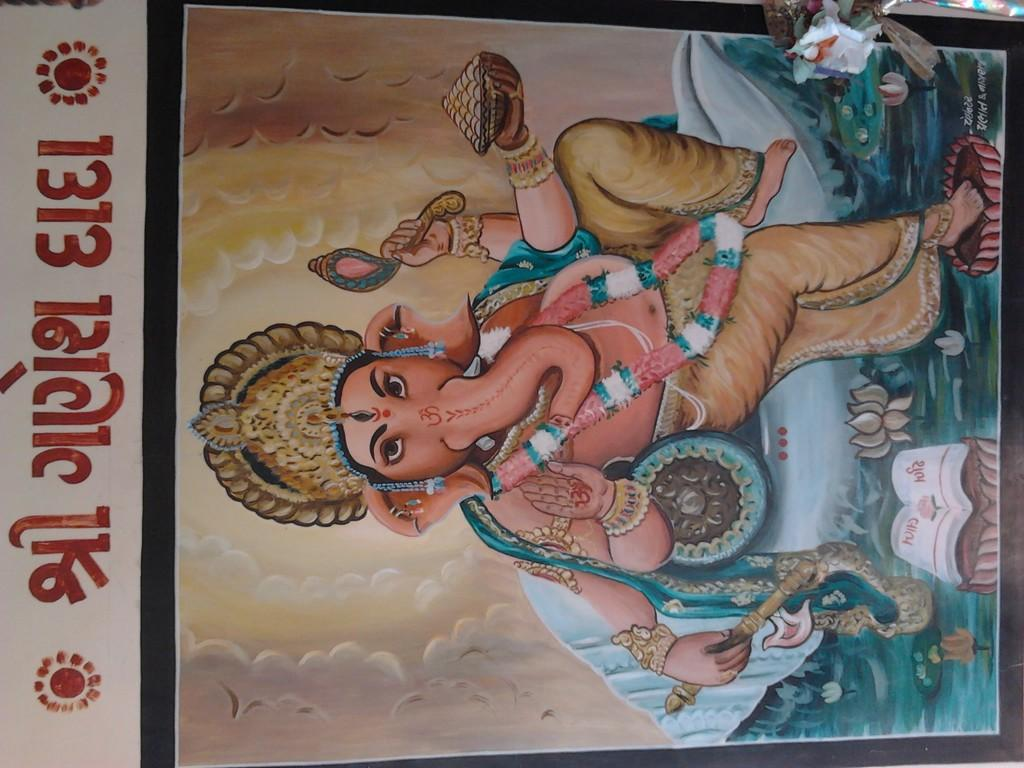What is the main subject of the image? There is a representation of Lord Ganesha in the center of the image. Can you describe any other elements in the image? There is some text on the left side of the image. Are there any fairies flying around Lord Ganesha in the image? No, there are no fairies present in the image. What type of division is being depicted in the image? The image does not depict any division; it features a representation of Lord Ganesha and some text. 